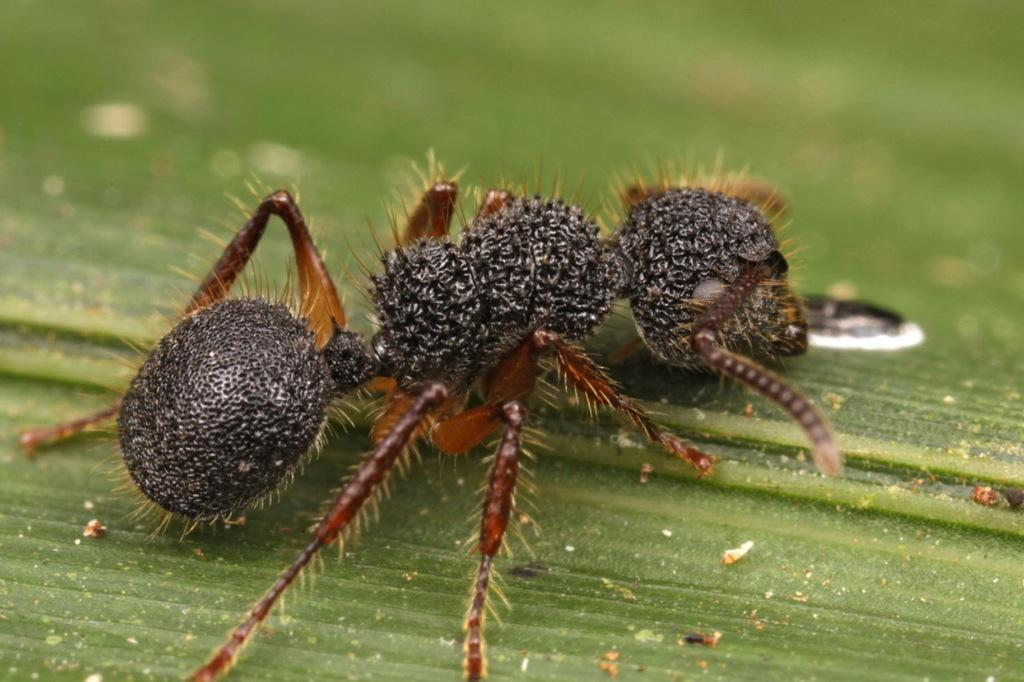What is present in the image? There is an insect in the image. Where is the insect located? The insect is on a leaf. What type of bag can be seen hanging from the leaf in the image? There is no bag present in the image; it only features an insect on a leaf. 